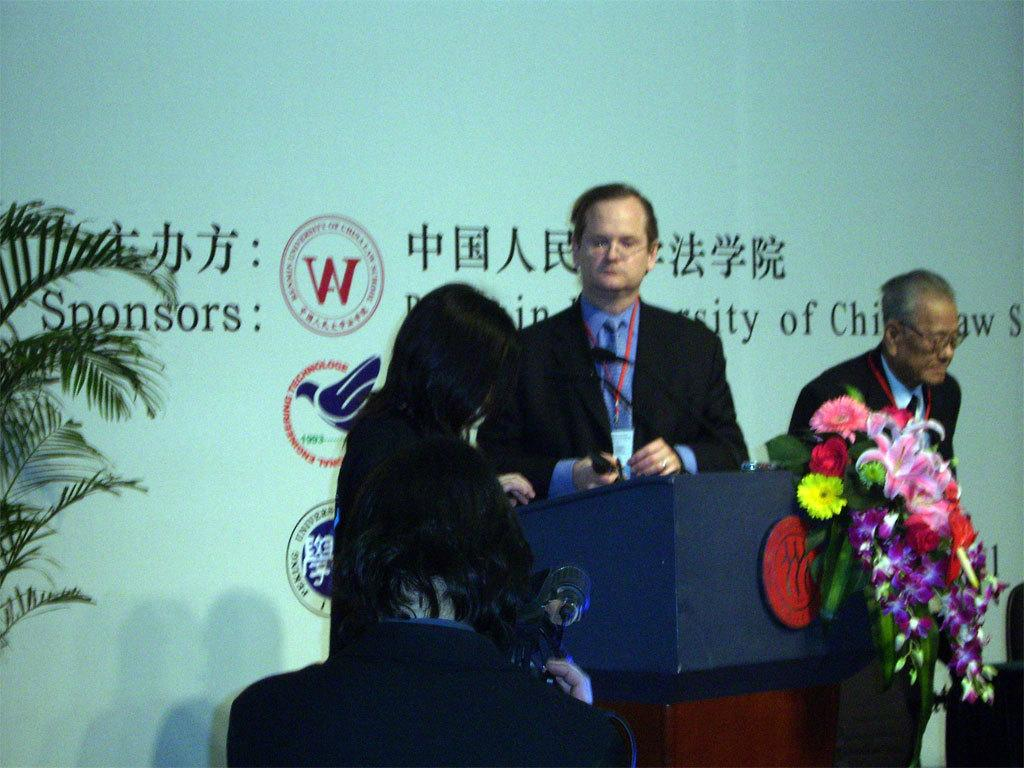How many people are in the image? There are three persons standing in the center of the image. What is in front of the persons? There is a wooden stand in front of the persons. What is on the wooden stand? There is a flower bouquet on the wooden stand. What can be seen in the background of the image? There is a banner and a plant in the background of the image. What type of texture can be seen on the goldfish in the image? There are no goldfish present in the image. Is the rifle visible in the image? There is no rifle present in the image. 